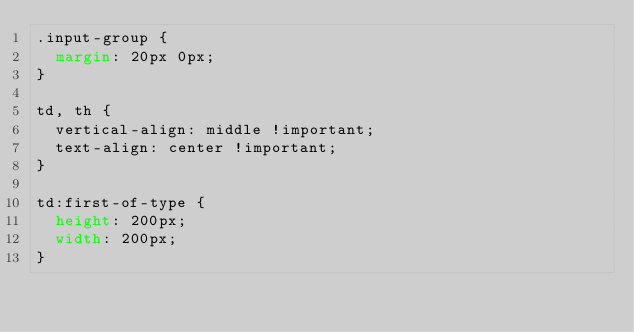Convert code to text. <code><loc_0><loc_0><loc_500><loc_500><_CSS_>.input-group {
  margin: 20px 0px;
}

td, th {
  vertical-align: middle !important;
  text-align: center !important;
}

td:first-of-type {
  height: 200px;
  width: 200px;
}
</code> 